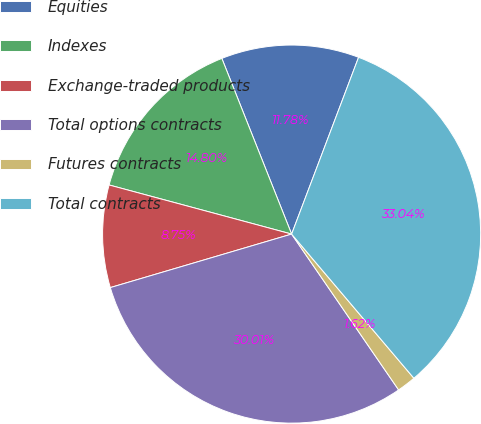Convert chart. <chart><loc_0><loc_0><loc_500><loc_500><pie_chart><fcel>Equities<fcel>Indexes<fcel>Exchange-traded products<fcel>Total options contracts<fcel>Futures contracts<fcel>Total contracts<nl><fcel>11.78%<fcel>14.8%<fcel>8.75%<fcel>30.01%<fcel>1.62%<fcel>33.04%<nl></chart> 